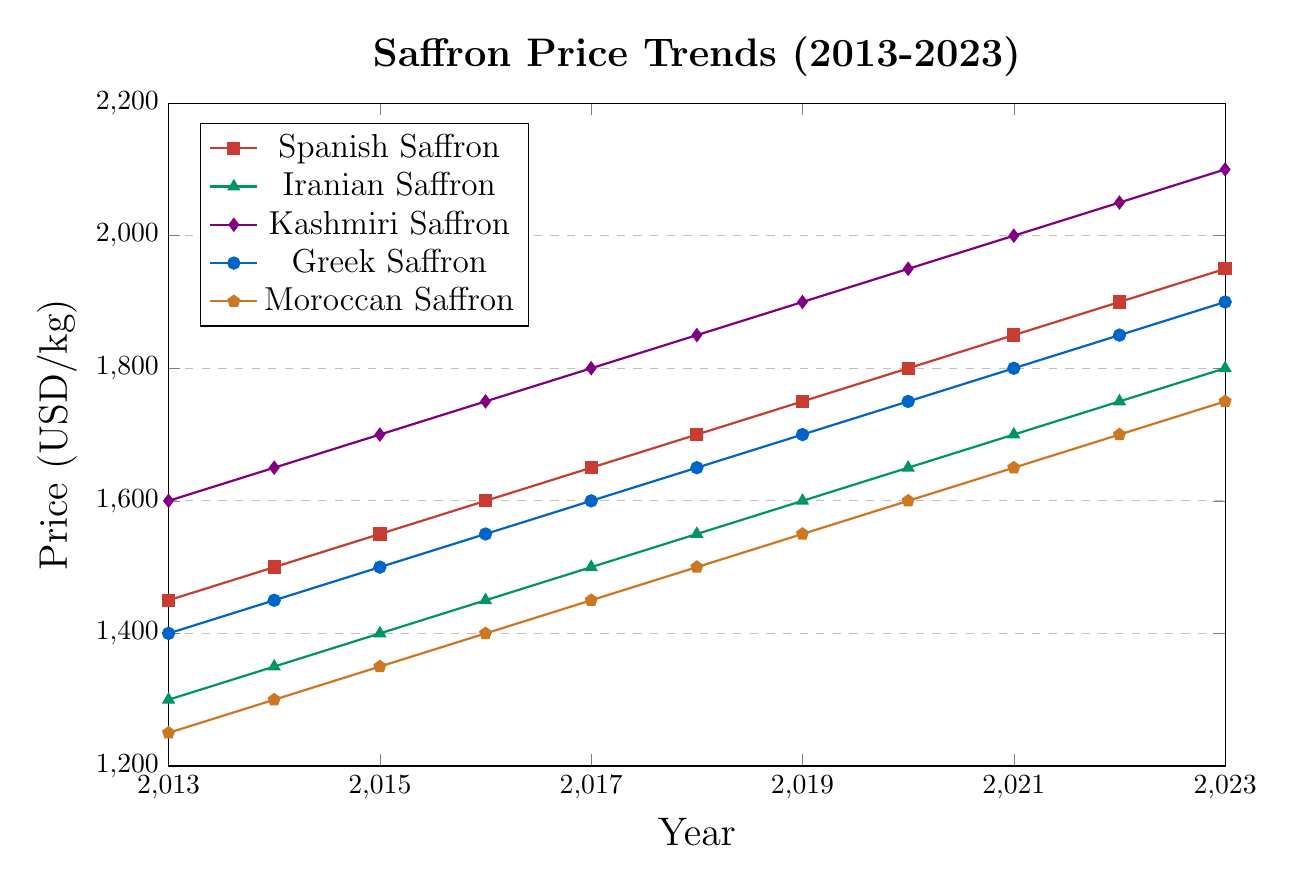Which region saw the fastest price increase between 2013 and 2023? To determine the fastest price increase, we need to calculate the price difference for each region from 2013 to 2023 and then compare these values. The differences are: Kashmiri Saffron: 2100-1600=500, Spanish Saffron: 1950-1450=500, Iranian Saffron: 1800-1300=500, Greek Saffron: 1900-1400=500, Moroccan Saffron: 1750-1250=500. Since they all have the same increase of 500 USD, the answer is that they all saw the same price increase.
Answer: All regions (500 USD) Which year shows the highest price for Iranian Saffron? Looking at the trend line for Iranian Saffron (green), the highest price is at the endpoint in 2023.
Answer: 2023 How does the price trend of Greek Saffron compare to Moroccan Saffron over the decade? By observing the slopes of the lines for Greek Saffron (blue) and Moroccan Saffron (ochre), both trends are consistently increasing. However, Greek Saffron prices are consistently higher than Moroccan Saffron, yet both have similar increasing rates starting from a lower price in 2013 and ending at relatively similar positions in 2023.
Answer: Greek Saffron has always been more expensive, but both increase similarly What is the difference in the prices of Kashmiri Saffron and Spanish Saffron in 2019? From observing the figure, the price of Kashmiri Saffron in 2019 is 1900 USD, and the price of Spanish Saffron is 1750 USD. The difference is 1900 - 1750.
Answer: 150 USD What is the average price of Iranian Saffron over the last decade? We add the yearly prices from 2013 to 2023 and divide by the number of years. (1300+1350+1400+1450+1500+1550+1600+1650+1700+1750+1800)/11 = 15050/11 = 1368.18
Answer: 1368.18 USD Which year shows the smallest price difference between Kashmiri Saffron and Greek Saffron? We calculate the annual differences: 
2013: 1600-1400=200,
2014: 1650-1450=200,
2015: 1700-1500=200,
2016: 1750-1550=200,
2017: 1800-1600=200,
2018: 1850-1650=200,
2019: 1900-1700=200,
2020: 1950-1750=200,
2021: 2000-1800=200,
2022: 2050-1850=200,
2023: 2100-1900=200.
All differences are the same across the years.
Answer: Every year (200 USD) Which saffron had the lowest price in 2020 and what was it? In 2020, the price trends show Moroccan Saffron as the lowest with a price of 1600 USD.
Answer: Moroccan Saffron, 1600 USD What is the combined price of Iranian Saffron and Greek Saffron in 2016? From the figure, Iranian Saffron price in 2016 is 1450 USD, and Greek Saffron is 1550 USD. The combined price is 1450 + 1550.
Answer: 3000 USD What is the median price of Spanish Saffron across the decade? To find the median, we list the prices and select the middle value. Prices in order: 1450, 1500, 1550, 1600, 1650, 1700, 1750, 1800, 1850, 1900, 1950. The middle value is the 6th value in this sequence.
Answer: 1700 USD 